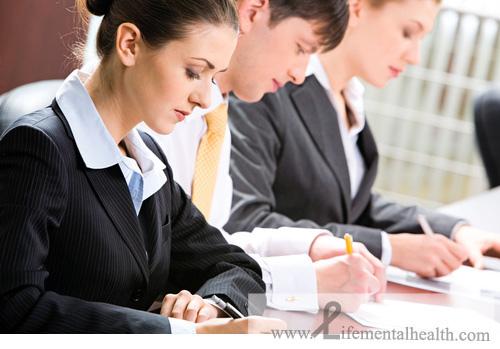Are these people at an outdoor music festival?
Write a very short answer. No. Do you think the girl in this photo looks like singer Katy Perry?
Quick response, please. Yes. Do the people in this scene look like they work in an office?
Concise answer only. Yes. 